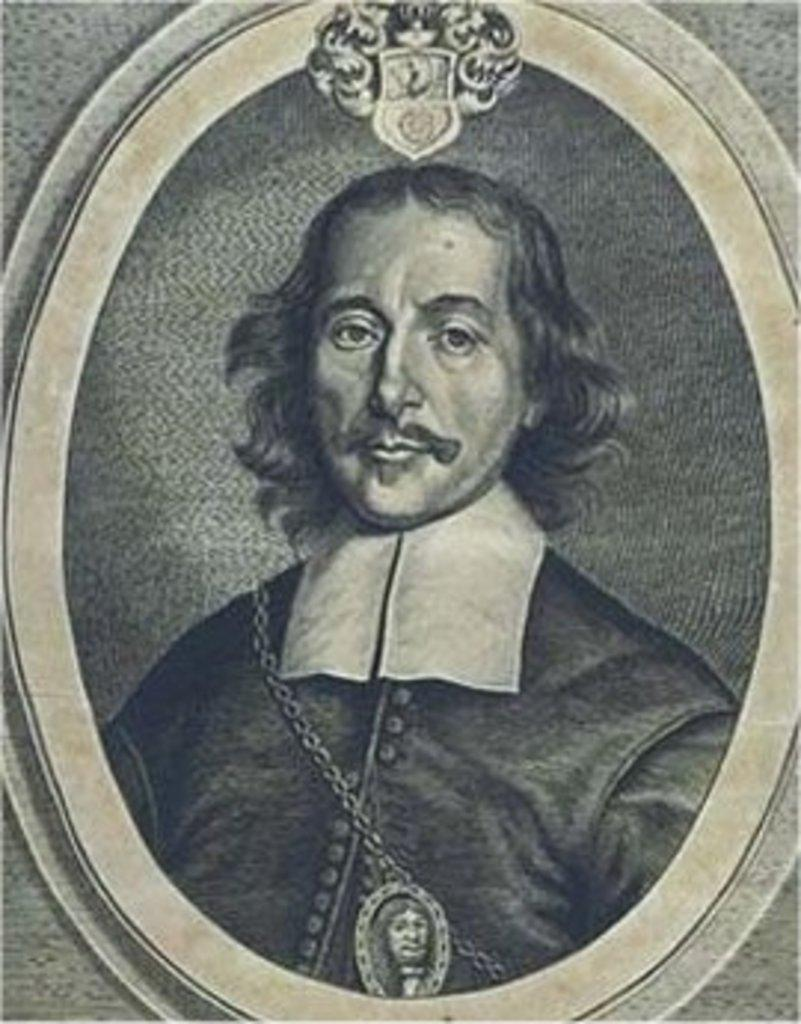What is the main subject of the image? The main subject of the image is a portrait. What is depicted within the portrait? The portrait contains an image of a person. How often does the person in the portrait wash their hands? The image in the portrait does not provide information about the person's habits, such as handwashing frequency. 